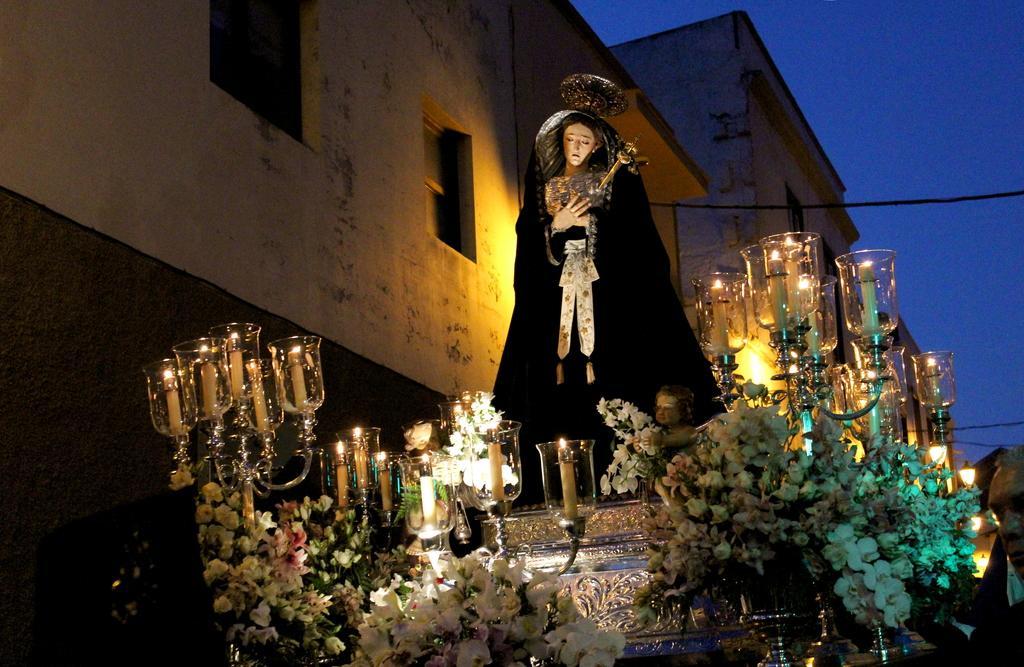Could you give a brief overview of what you see in this image? There is a statue. Near to that there are candles with stands. There are flower bouquets. On the sides there are buildings. In the background there is sky. 